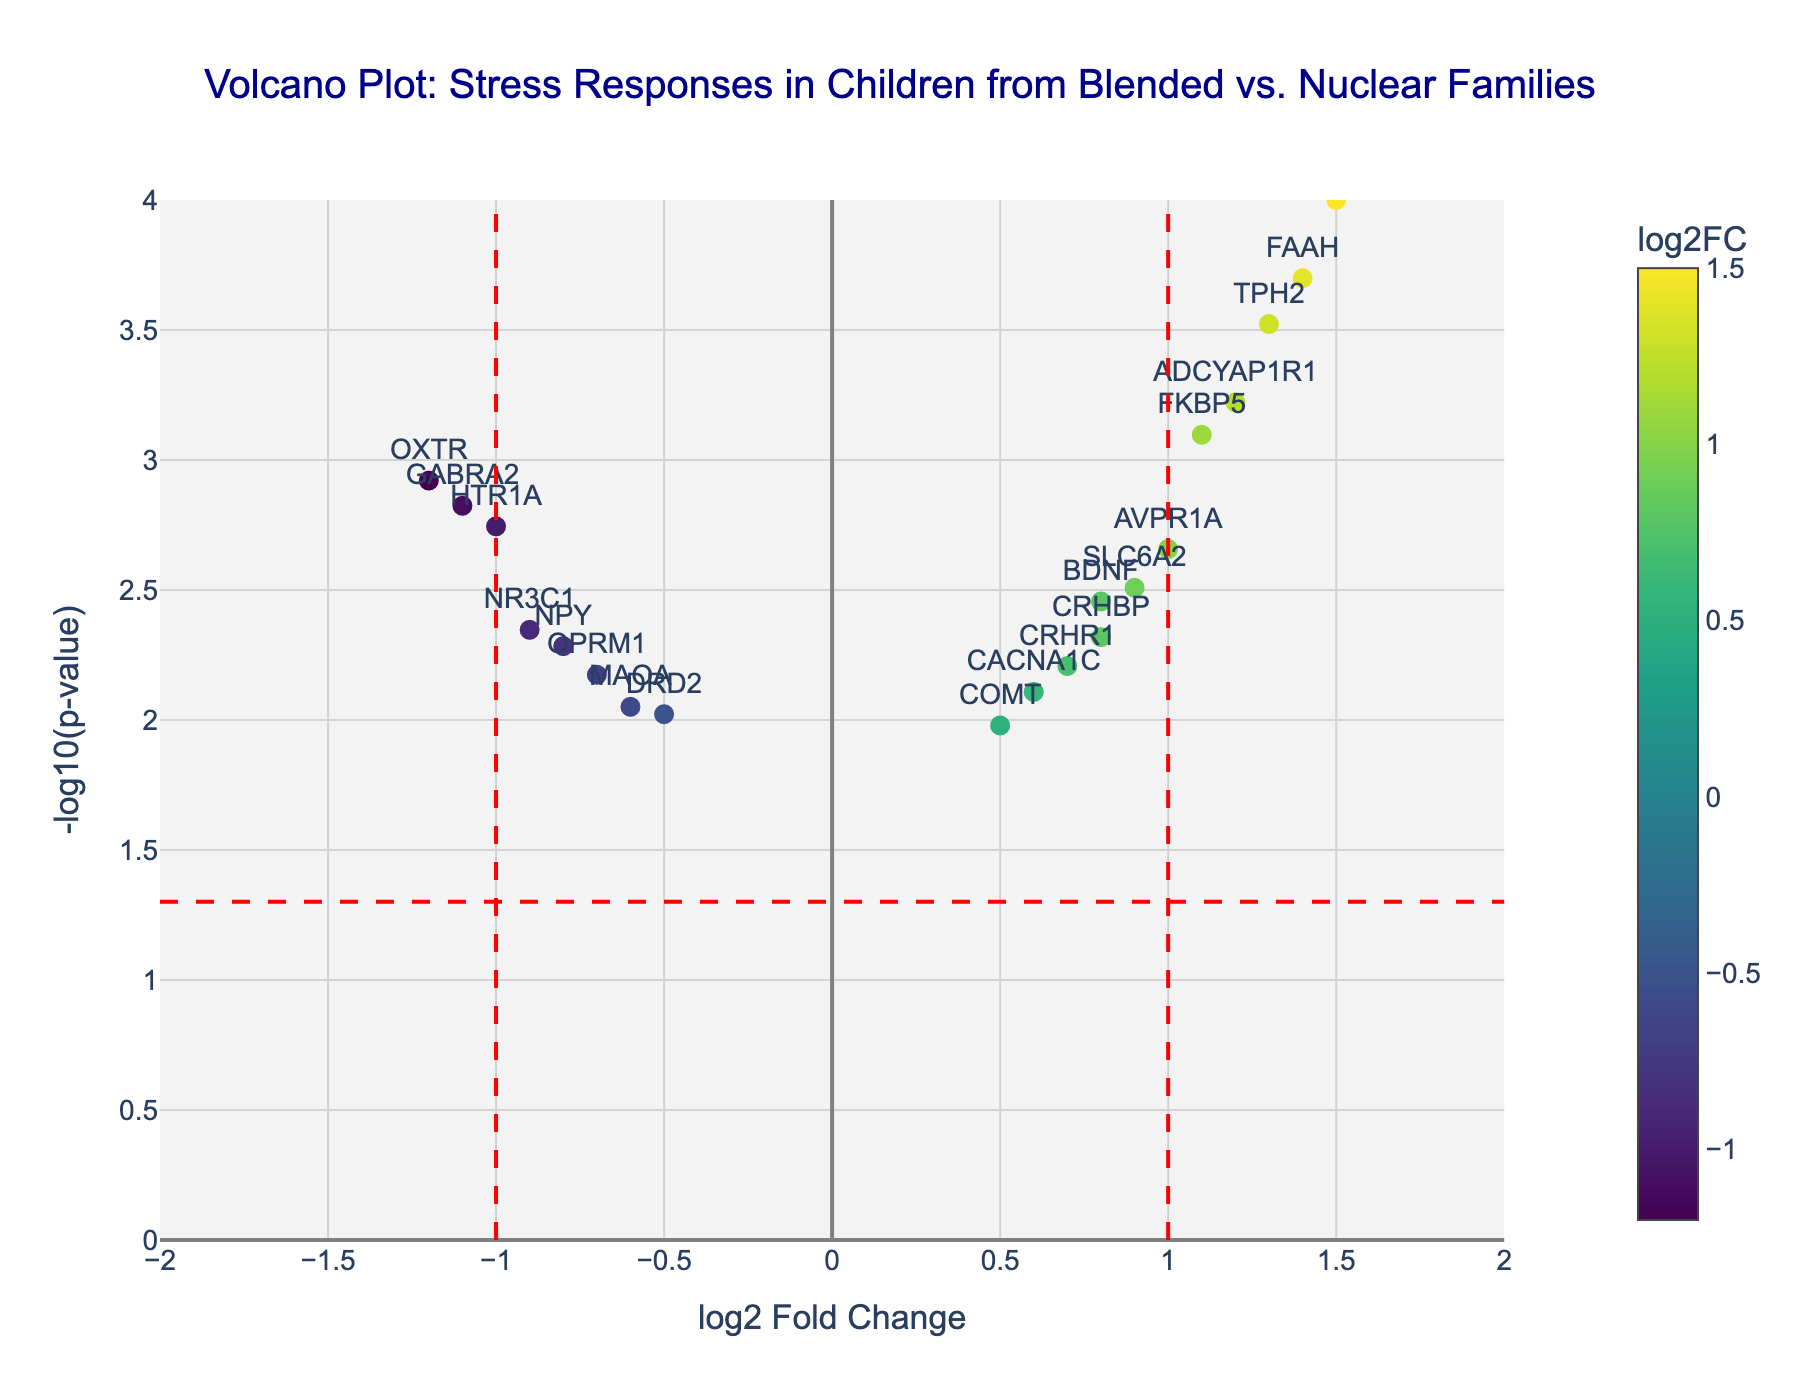What is the title of the plot? The title of the plot is prominently displayed at the top and reads "Volcano Plot: Stress Responses in Children from Blended vs. Nuclear Families".
Answer: Volcano Plot: Stress Responses in Children from Blended vs. Nuclear Families How many data points are displayed in the plot? Each gene in the data set is represented by a marker in the plot. By counting the markers or the genes listed, there are 20 data points.
Answer: 20 What do the colors of the markers represent? The color of the markers is determined by the log2 fold change values, which vary according to a Viridis color scale.
Answer: log2 Fold Change Which gene has the lowest p-value? The gene with the lowest p-value will have the highest -log10(p-value) value on the y-axis. It corresponds to SLC6A4, which has a p-value of 0.0001.
Answer: SLC6A4 What is the role of the horizontal and vertical dashed lines? The vertical dashed lines represent the cut-off thresholds at log2 fold change values of -1 and 1. The horizontal dashed line represents the p-value cut-off threshold of 0.05, corresponding to -log10(0.05).
Answer: Thresholds How many genes have a log2 fold change greater than 1 and a p-value less than 0.05? We need to count genes having log2 fold change > 1 and -log10(p-value) values above the horizontal threshold line, which are SLC6A4, TPH2, ADCYAP1R1, AVPR1A, and FAAH.
Answer: 5 Which gene has the most negative log2 fold change with a significant p-value? The most negative log2 fold change with significant p-value is the point farthest left beyond the vertical line (-1) and above the horizontal line. This corresponds to OXTR.
Answer: OXTR Compare genes HTR1A and FAAH in terms of log2 fold change. Which one has a higher value? Locate HTR1A and FAAH on the plot. HTR1A has a log2 fold change of -1.0, while FAAH has a log2 fold change of 1.4.
Answer: FAAH What are the log2 fold change and p-value for the gene BDNF? The values for BDNF can be found by locating it on the plot and examining the marker's hover text, which shows a log2 fold change of 0.8 and a p-value of 0.0035.
Answer: log2 fold change: 0.8, p-value: 0.0035 Identify a gene that has a non-significant p-value and provide its log2 fold change. Genes without significant p-values are below the horizontal threshold line. An example is DRD2, which has a log2 fold change of -0.5 and a p-value of 0.0095.
Answer: DRD2, log2 fold change: -0.5 